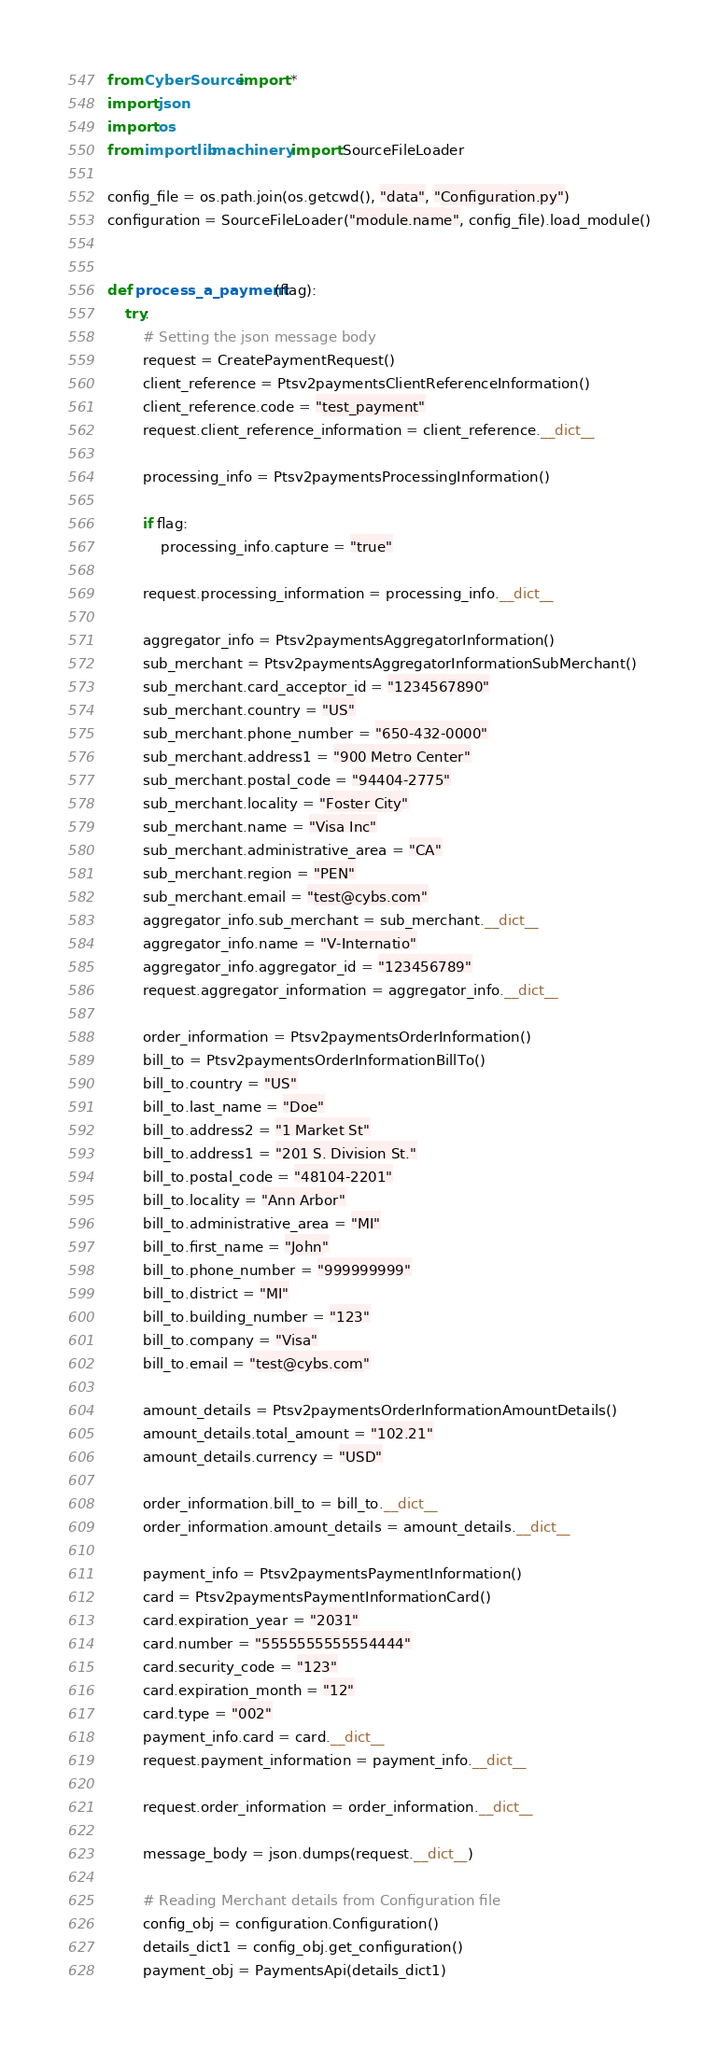Convert code to text. <code><loc_0><loc_0><loc_500><loc_500><_Python_>from CyberSource import *
import json
import os
from importlib.machinery import SourceFileLoader

config_file = os.path.join(os.getcwd(), "data", "Configuration.py")
configuration = SourceFileLoader("module.name", config_file).load_module()


def process_a_payment(flag):
    try:
        # Setting the json message body
        request = CreatePaymentRequest()
        client_reference = Ptsv2paymentsClientReferenceInformation()
        client_reference.code = "test_payment"
        request.client_reference_information = client_reference.__dict__

        processing_info = Ptsv2paymentsProcessingInformation()

        if flag:
            processing_info.capture = "true"

        request.processing_information = processing_info.__dict__

        aggregator_info = Ptsv2paymentsAggregatorInformation()
        sub_merchant = Ptsv2paymentsAggregatorInformationSubMerchant()
        sub_merchant.card_acceptor_id = "1234567890"
        sub_merchant.country = "US"
        sub_merchant.phone_number = "650-432-0000"
        sub_merchant.address1 = "900 Metro Center"
        sub_merchant.postal_code = "94404-2775"
        sub_merchant.locality = "Foster City"
        sub_merchant.name = "Visa Inc"
        sub_merchant.administrative_area = "CA"
        sub_merchant.region = "PEN"
        sub_merchant.email = "test@cybs.com"
        aggregator_info.sub_merchant = sub_merchant.__dict__
        aggregator_info.name = "V-Internatio"
        aggregator_info.aggregator_id = "123456789"
        request.aggregator_information = aggregator_info.__dict__

        order_information = Ptsv2paymentsOrderInformation()
        bill_to = Ptsv2paymentsOrderInformationBillTo()
        bill_to.country = "US"
        bill_to.last_name = "Doe"
        bill_to.address2 = "1 Market St"
        bill_to.address1 = "201 S. Division St."
        bill_to.postal_code = "48104-2201"
        bill_to.locality = "Ann Arbor"
        bill_to.administrative_area = "MI"
        bill_to.first_name = "John"
        bill_to.phone_number = "999999999"
        bill_to.district = "MI"
        bill_to.building_number = "123"
        bill_to.company = "Visa"
        bill_to.email = "test@cybs.com"

        amount_details = Ptsv2paymentsOrderInformationAmountDetails()
        amount_details.total_amount = "102.21"
        amount_details.currency = "USD"

        order_information.bill_to = bill_to.__dict__
        order_information.amount_details = amount_details.__dict__

        payment_info = Ptsv2paymentsPaymentInformation()
        card = Ptsv2paymentsPaymentInformationCard()
        card.expiration_year = "2031"
        card.number = "5555555555554444"
        card.security_code = "123"
        card.expiration_month = "12"
        card.type = "002"
        payment_info.card = card.__dict__
        request.payment_information = payment_info.__dict__

        request.order_information = order_information.__dict__

        message_body = json.dumps(request.__dict__)

        # Reading Merchant details from Configuration file
        config_obj = configuration.Configuration()
        details_dict1 = config_obj.get_configuration()
        payment_obj = PaymentsApi(details_dict1)</code> 